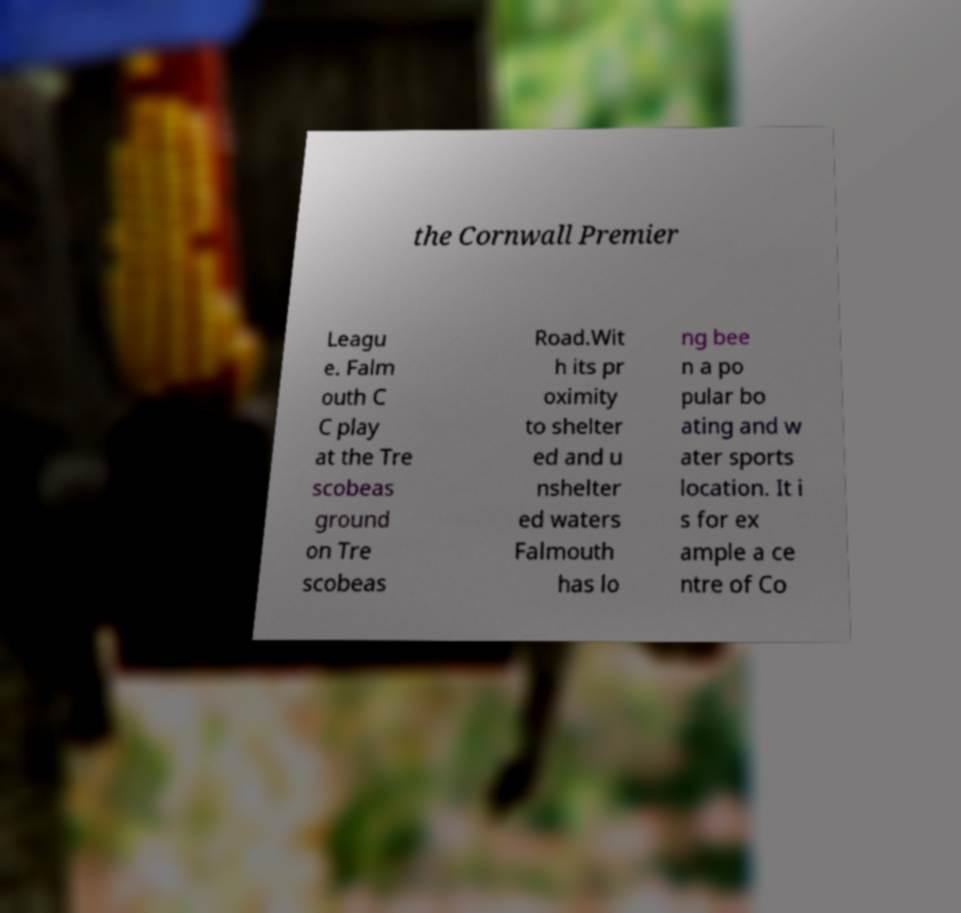Could you assist in decoding the text presented in this image and type it out clearly? the Cornwall Premier Leagu e. Falm outh C C play at the Tre scobeas ground on Tre scobeas Road.Wit h its pr oximity to shelter ed and u nshelter ed waters Falmouth has lo ng bee n a po pular bo ating and w ater sports location. It i s for ex ample a ce ntre of Co 